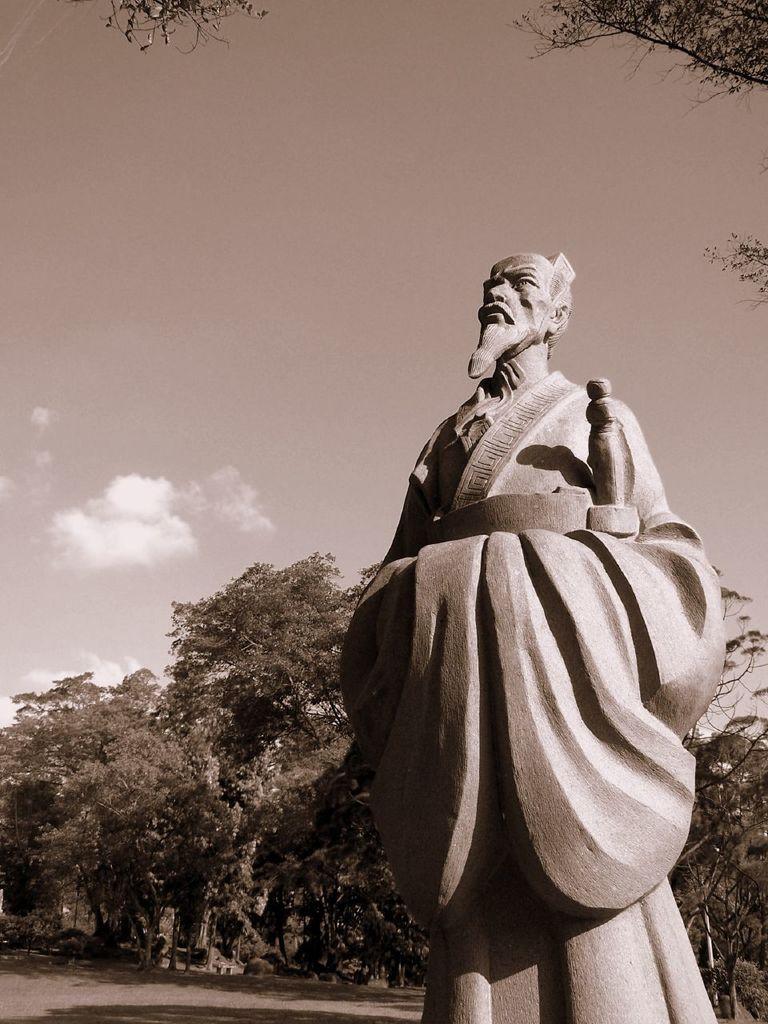Could you give a brief overview of what you see in this image? In the foreground there is a statue. At the top there are tree branches. In the background there are trees. Sky is clear and it is sunny. 